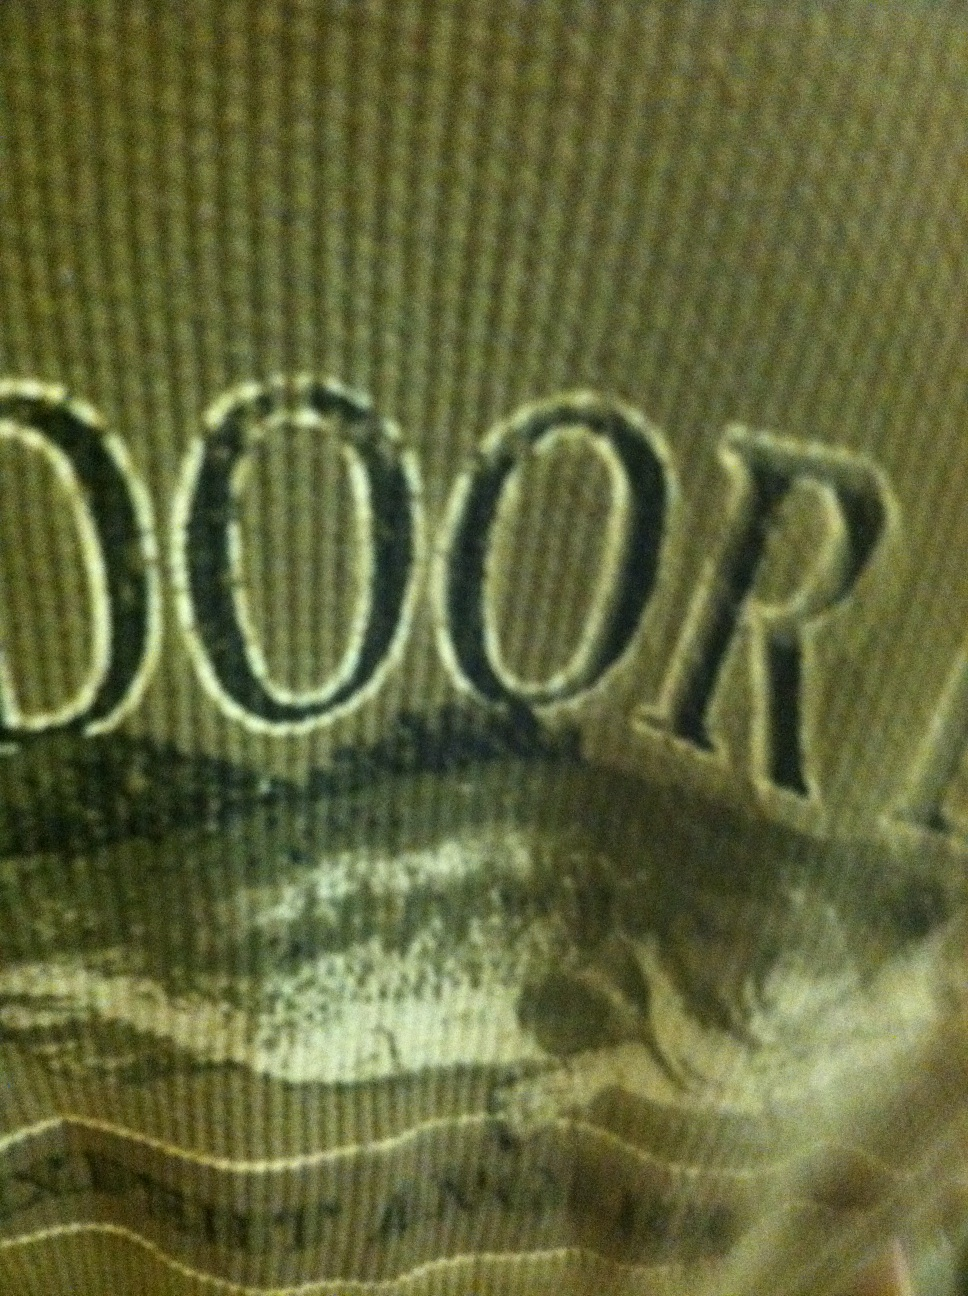What kind of fabric do you think this shirt is made of, considering its color and texture? Given the texture and color of the shirt, it might be made from a durable, breathable fabric such as cotton or a cotton-blend. This type of material would be comfortable for outdoor activities, keeping the wearer cool and dry. 